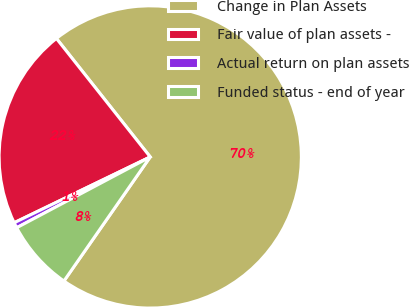Convert chart to OTSL. <chart><loc_0><loc_0><loc_500><loc_500><pie_chart><fcel>Change in Plan Assets<fcel>Fair value of plan assets -<fcel>Actual return on plan assets<fcel>Funded status - end of year<nl><fcel>70.33%<fcel>21.51%<fcel>0.59%<fcel>7.57%<nl></chart> 